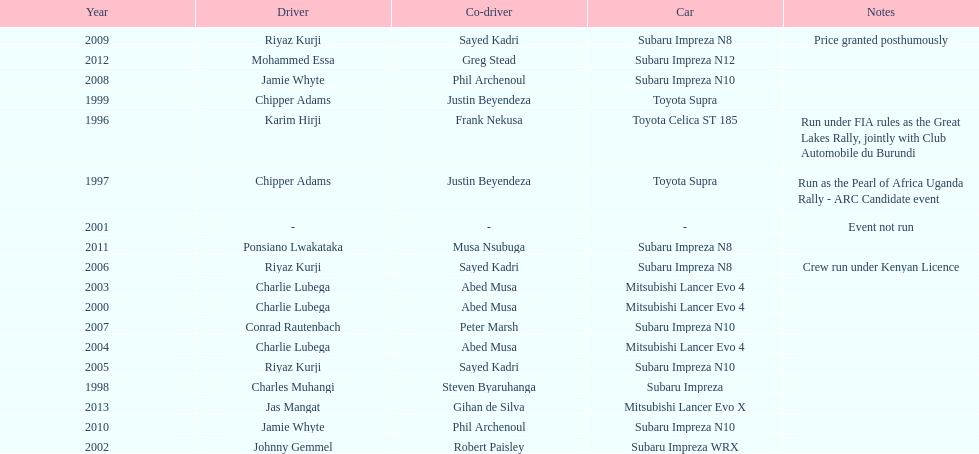Which was the only year that the event was not run? 2001. 